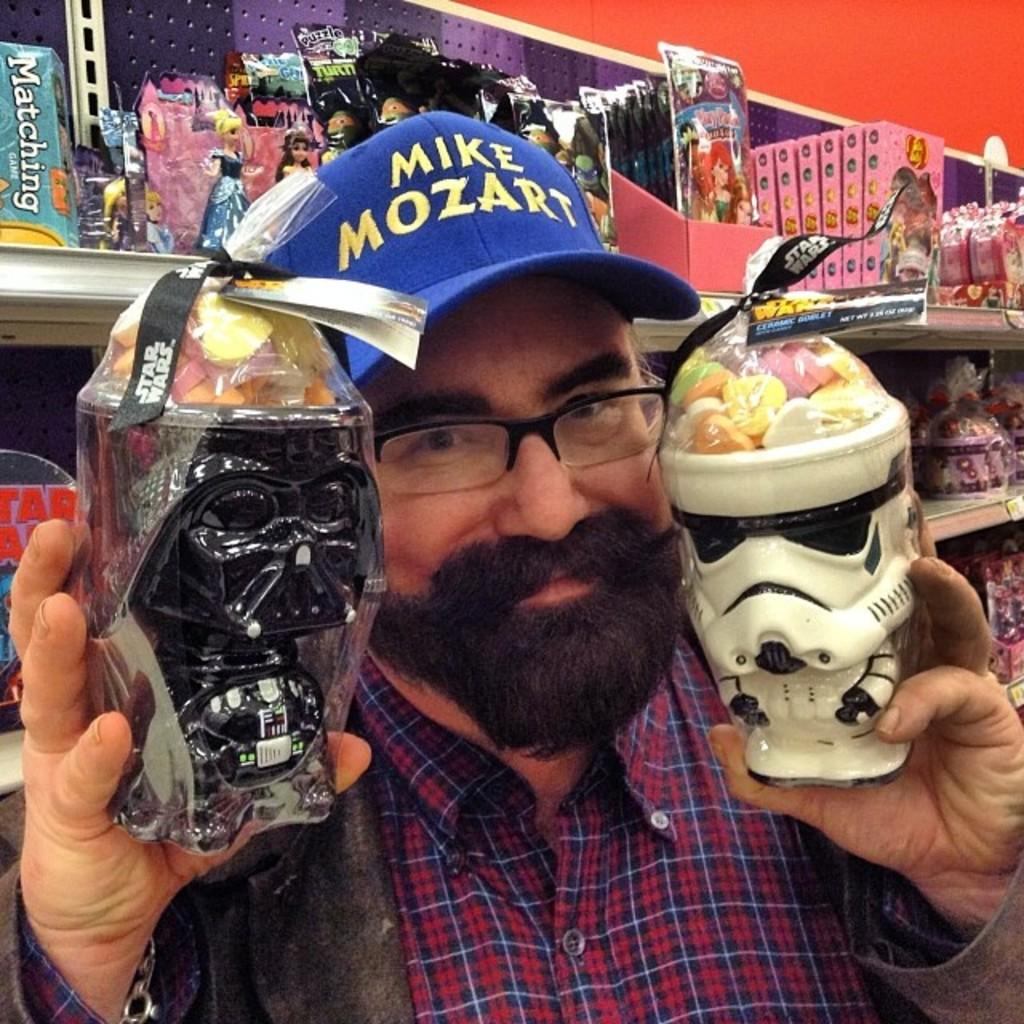Who is present in the image? There is a man in the image. What is the man holding in the image? The man is holding two boxes. What is inside the boxes? There are jellies in the boxes. What can be seen in the background of the image? There is a shelf in the background of the image. What is on the shelf? There are objects on the shelf. What is the maid's name in the image? There is no maid present in the image. What is the man's desire in the image? The image does not provide information about the man's desires. 